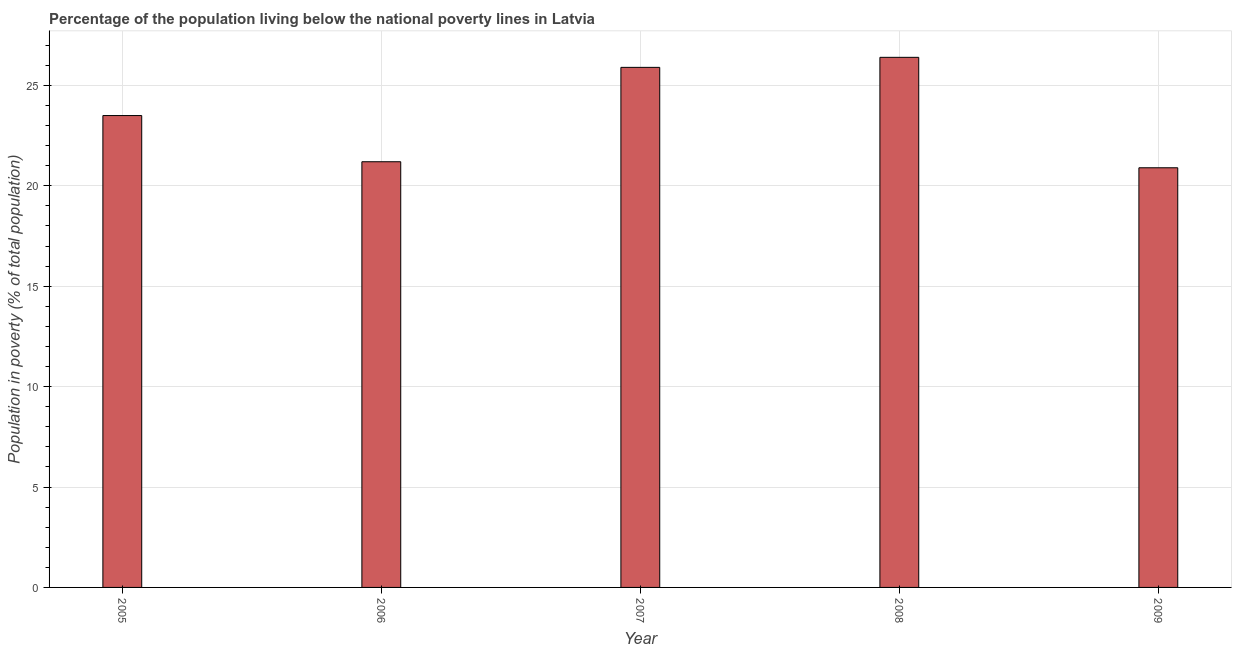Does the graph contain any zero values?
Offer a terse response. No. Does the graph contain grids?
Offer a terse response. Yes. What is the title of the graph?
Provide a short and direct response. Percentage of the population living below the national poverty lines in Latvia. What is the label or title of the X-axis?
Provide a succinct answer. Year. What is the label or title of the Y-axis?
Make the answer very short. Population in poverty (% of total population). What is the percentage of population living below poverty line in 2007?
Your response must be concise. 25.9. Across all years, what is the maximum percentage of population living below poverty line?
Provide a short and direct response. 26.4. Across all years, what is the minimum percentage of population living below poverty line?
Keep it short and to the point. 20.9. What is the sum of the percentage of population living below poverty line?
Provide a succinct answer. 117.9. What is the difference between the percentage of population living below poverty line in 2006 and 2007?
Provide a short and direct response. -4.7. What is the average percentage of population living below poverty line per year?
Your response must be concise. 23.58. What is the median percentage of population living below poverty line?
Provide a short and direct response. 23.5. In how many years, is the percentage of population living below poverty line greater than 16 %?
Offer a terse response. 5. Do a majority of the years between 2008 and 2005 (inclusive) have percentage of population living below poverty line greater than 20 %?
Offer a very short reply. Yes. What is the ratio of the percentage of population living below poverty line in 2006 to that in 2009?
Provide a short and direct response. 1.01. Is the difference between the percentage of population living below poverty line in 2007 and 2009 greater than the difference between any two years?
Offer a terse response. No. What is the difference between the highest and the second highest percentage of population living below poverty line?
Offer a terse response. 0.5. Are all the bars in the graph horizontal?
Offer a terse response. No. What is the difference between two consecutive major ticks on the Y-axis?
Your answer should be very brief. 5. What is the Population in poverty (% of total population) of 2005?
Your answer should be very brief. 23.5. What is the Population in poverty (% of total population) of 2006?
Provide a succinct answer. 21.2. What is the Population in poverty (% of total population) of 2007?
Provide a short and direct response. 25.9. What is the Population in poverty (% of total population) in 2008?
Make the answer very short. 26.4. What is the Population in poverty (% of total population) in 2009?
Your response must be concise. 20.9. What is the difference between the Population in poverty (% of total population) in 2005 and 2006?
Provide a short and direct response. 2.3. What is the difference between the Population in poverty (% of total population) in 2005 and 2008?
Ensure brevity in your answer.  -2.9. What is the difference between the Population in poverty (% of total population) in 2005 and 2009?
Your response must be concise. 2.6. What is the difference between the Population in poverty (% of total population) in 2006 and 2007?
Your response must be concise. -4.7. What is the difference between the Population in poverty (% of total population) in 2006 and 2009?
Provide a short and direct response. 0.3. What is the difference between the Population in poverty (% of total population) in 2007 and 2008?
Offer a terse response. -0.5. What is the difference between the Population in poverty (% of total population) in 2007 and 2009?
Your answer should be compact. 5. What is the ratio of the Population in poverty (% of total population) in 2005 to that in 2006?
Ensure brevity in your answer.  1.11. What is the ratio of the Population in poverty (% of total population) in 2005 to that in 2007?
Offer a terse response. 0.91. What is the ratio of the Population in poverty (% of total population) in 2005 to that in 2008?
Your response must be concise. 0.89. What is the ratio of the Population in poverty (% of total population) in 2005 to that in 2009?
Make the answer very short. 1.12. What is the ratio of the Population in poverty (% of total population) in 2006 to that in 2007?
Ensure brevity in your answer.  0.82. What is the ratio of the Population in poverty (% of total population) in 2006 to that in 2008?
Make the answer very short. 0.8. What is the ratio of the Population in poverty (% of total population) in 2007 to that in 2008?
Provide a short and direct response. 0.98. What is the ratio of the Population in poverty (% of total population) in 2007 to that in 2009?
Your response must be concise. 1.24. What is the ratio of the Population in poverty (% of total population) in 2008 to that in 2009?
Offer a terse response. 1.26. 